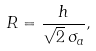Convert formula to latex. <formula><loc_0><loc_0><loc_500><loc_500>R = \frac { h } { \sqrt { 2 } \, \sigma _ { a } } ,</formula> 